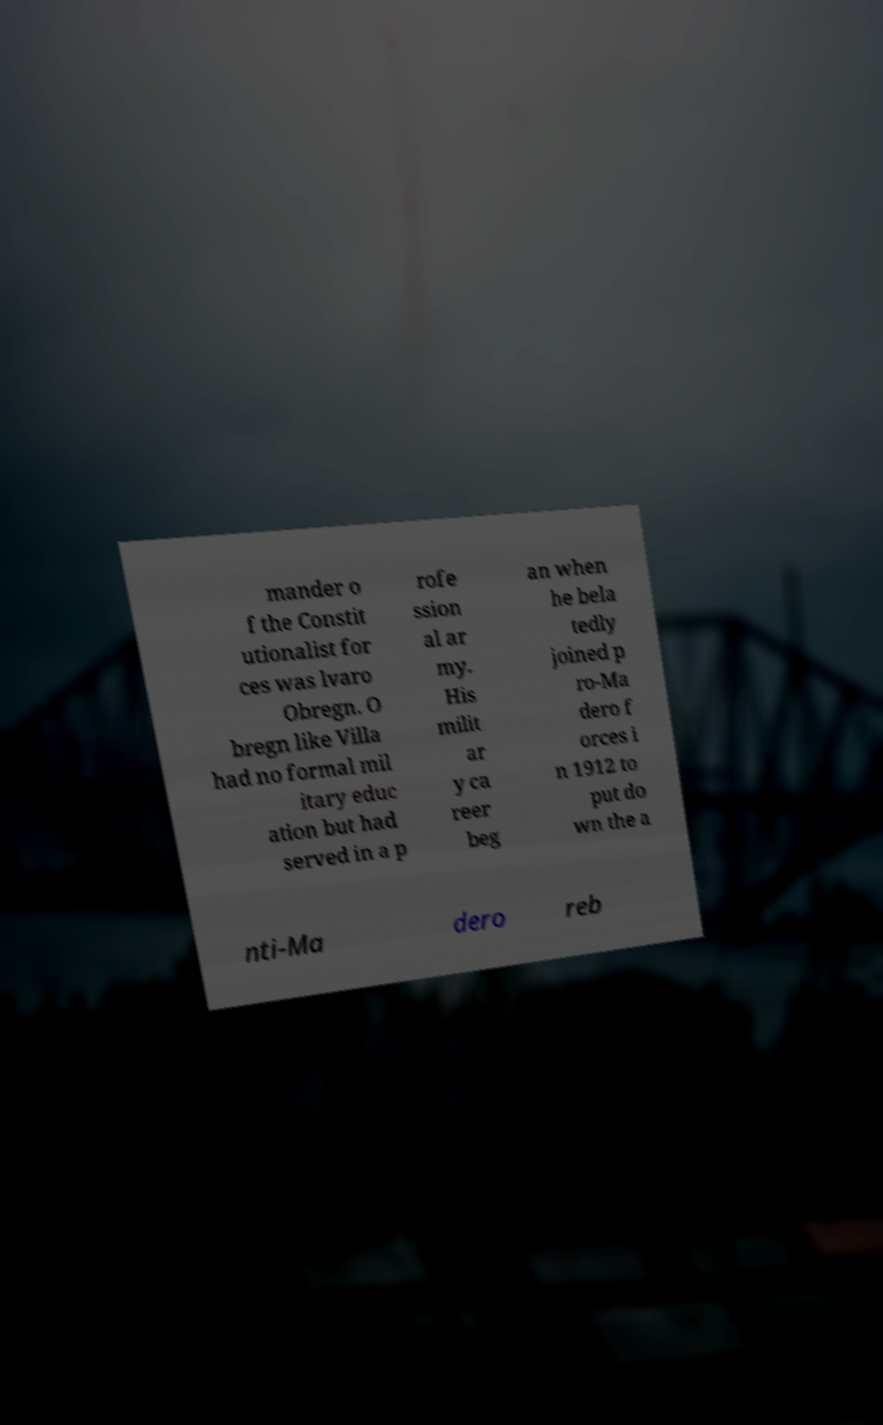Can you read and provide the text displayed in the image?This photo seems to have some interesting text. Can you extract and type it out for me? mander o f the Constit utionalist for ces was lvaro Obregn. O bregn like Villa had no formal mil itary educ ation but had served in a p rofe ssion al ar my. His milit ar y ca reer beg an when he bela tedly joined p ro-Ma dero f orces i n 1912 to put do wn the a nti-Ma dero reb 